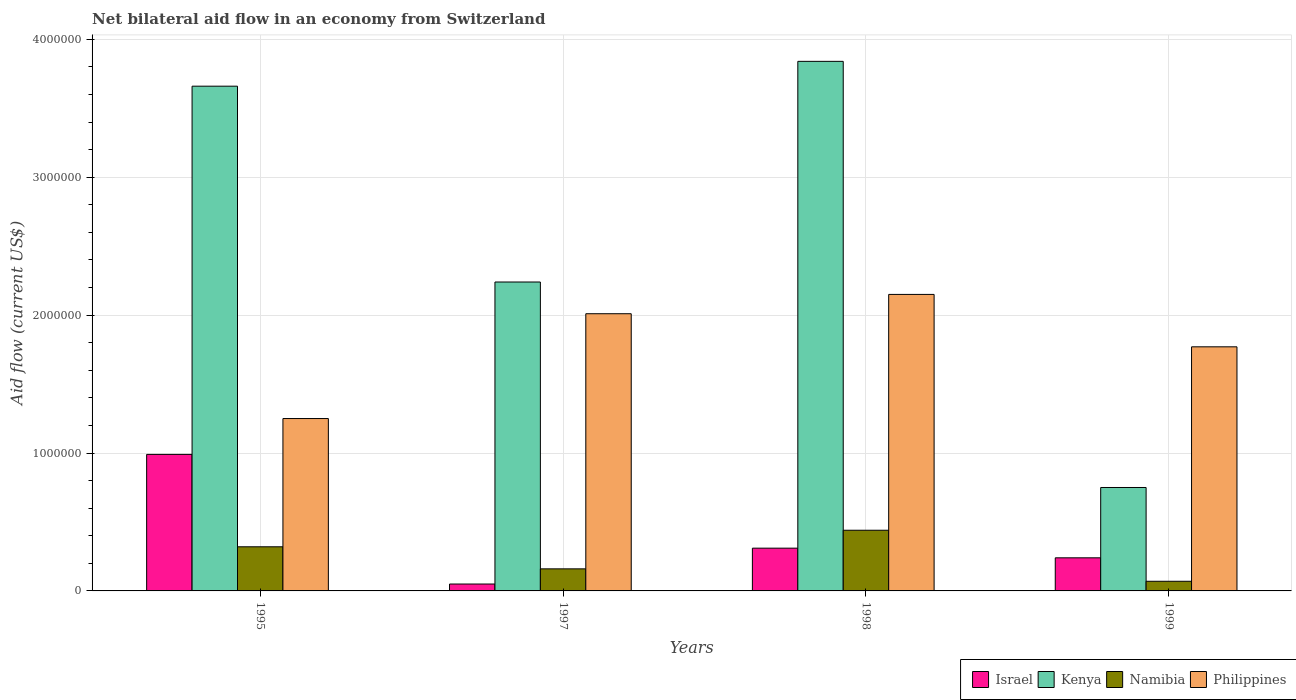How many different coloured bars are there?
Your response must be concise. 4. How many groups of bars are there?
Make the answer very short. 4. Are the number of bars per tick equal to the number of legend labels?
Your answer should be very brief. Yes. Are the number of bars on each tick of the X-axis equal?
Offer a terse response. Yes. How many bars are there on the 2nd tick from the left?
Offer a terse response. 4. What is the label of the 4th group of bars from the left?
Your answer should be compact. 1999. What is the net bilateral aid flow in Israel in 1995?
Offer a terse response. 9.90e+05. Across all years, what is the maximum net bilateral aid flow in Philippines?
Provide a short and direct response. 2.15e+06. Across all years, what is the minimum net bilateral aid flow in Philippines?
Provide a short and direct response. 1.25e+06. In which year was the net bilateral aid flow in Kenya maximum?
Ensure brevity in your answer.  1998. What is the total net bilateral aid flow in Israel in the graph?
Offer a terse response. 1.59e+06. What is the difference between the net bilateral aid flow in Namibia in 1997 and that in 1998?
Your answer should be very brief. -2.80e+05. What is the difference between the net bilateral aid flow in Kenya in 1997 and the net bilateral aid flow in Namibia in 1998?
Keep it short and to the point. 1.80e+06. What is the average net bilateral aid flow in Kenya per year?
Offer a very short reply. 2.62e+06. In the year 1999, what is the difference between the net bilateral aid flow in Namibia and net bilateral aid flow in Kenya?
Your response must be concise. -6.80e+05. What is the ratio of the net bilateral aid flow in Philippines in 1995 to that in 1998?
Ensure brevity in your answer.  0.58. What is the difference between the highest and the second highest net bilateral aid flow in Israel?
Provide a succinct answer. 6.80e+05. What is the difference between the highest and the lowest net bilateral aid flow in Israel?
Keep it short and to the point. 9.40e+05. In how many years, is the net bilateral aid flow in Israel greater than the average net bilateral aid flow in Israel taken over all years?
Your response must be concise. 1. What does the 2nd bar from the left in 1999 represents?
Make the answer very short. Kenya. What does the 4th bar from the right in 1998 represents?
Your answer should be compact. Israel. Are all the bars in the graph horizontal?
Give a very brief answer. No. How many years are there in the graph?
Your response must be concise. 4. What is the difference between two consecutive major ticks on the Y-axis?
Ensure brevity in your answer.  1.00e+06. Does the graph contain any zero values?
Provide a short and direct response. No. Does the graph contain grids?
Offer a very short reply. Yes. Where does the legend appear in the graph?
Your answer should be compact. Bottom right. What is the title of the graph?
Your response must be concise. Net bilateral aid flow in an economy from Switzerland. What is the label or title of the Y-axis?
Give a very brief answer. Aid flow (current US$). What is the Aid flow (current US$) in Israel in 1995?
Offer a terse response. 9.90e+05. What is the Aid flow (current US$) of Kenya in 1995?
Offer a very short reply. 3.66e+06. What is the Aid flow (current US$) of Namibia in 1995?
Make the answer very short. 3.20e+05. What is the Aid flow (current US$) in Philippines in 1995?
Your response must be concise. 1.25e+06. What is the Aid flow (current US$) in Kenya in 1997?
Provide a succinct answer. 2.24e+06. What is the Aid flow (current US$) of Philippines in 1997?
Your answer should be very brief. 2.01e+06. What is the Aid flow (current US$) of Kenya in 1998?
Your answer should be very brief. 3.84e+06. What is the Aid flow (current US$) in Philippines in 1998?
Offer a terse response. 2.15e+06. What is the Aid flow (current US$) in Kenya in 1999?
Provide a short and direct response. 7.50e+05. What is the Aid flow (current US$) in Namibia in 1999?
Ensure brevity in your answer.  7.00e+04. What is the Aid flow (current US$) of Philippines in 1999?
Give a very brief answer. 1.77e+06. Across all years, what is the maximum Aid flow (current US$) in Israel?
Your response must be concise. 9.90e+05. Across all years, what is the maximum Aid flow (current US$) in Kenya?
Your answer should be compact. 3.84e+06. Across all years, what is the maximum Aid flow (current US$) in Namibia?
Keep it short and to the point. 4.40e+05. Across all years, what is the maximum Aid flow (current US$) in Philippines?
Your answer should be very brief. 2.15e+06. Across all years, what is the minimum Aid flow (current US$) in Kenya?
Provide a short and direct response. 7.50e+05. Across all years, what is the minimum Aid flow (current US$) of Namibia?
Offer a very short reply. 7.00e+04. Across all years, what is the minimum Aid flow (current US$) in Philippines?
Provide a succinct answer. 1.25e+06. What is the total Aid flow (current US$) of Israel in the graph?
Provide a short and direct response. 1.59e+06. What is the total Aid flow (current US$) in Kenya in the graph?
Your response must be concise. 1.05e+07. What is the total Aid flow (current US$) of Namibia in the graph?
Your response must be concise. 9.90e+05. What is the total Aid flow (current US$) of Philippines in the graph?
Keep it short and to the point. 7.18e+06. What is the difference between the Aid flow (current US$) in Israel in 1995 and that in 1997?
Offer a very short reply. 9.40e+05. What is the difference between the Aid flow (current US$) of Kenya in 1995 and that in 1997?
Provide a short and direct response. 1.42e+06. What is the difference between the Aid flow (current US$) of Namibia in 1995 and that in 1997?
Give a very brief answer. 1.60e+05. What is the difference between the Aid flow (current US$) of Philippines in 1995 and that in 1997?
Give a very brief answer. -7.60e+05. What is the difference between the Aid flow (current US$) in Israel in 1995 and that in 1998?
Make the answer very short. 6.80e+05. What is the difference between the Aid flow (current US$) in Kenya in 1995 and that in 1998?
Offer a terse response. -1.80e+05. What is the difference between the Aid flow (current US$) of Philippines in 1995 and that in 1998?
Provide a short and direct response. -9.00e+05. What is the difference between the Aid flow (current US$) in Israel in 1995 and that in 1999?
Your answer should be very brief. 7.50e+05. What is the difference between the Aid flow (current US$) in Kenya in 1995 and that in 1999?
Offer a terse response. 2.91e+06. What is the difference between the Aid flow (current US$) of Philippines in 1995 and that in 1999?
Ensure brevity in your answer.  -5.20e+05. What is the difference between the Aid flow (current US$) in Kenya in 1997 and that in 1998?
Ensure brevity in your answer.  -1.60e+06. What is the difference between the Aid flow (current US$) of Namibia in 1997 and that in 1998?
Your response must be concise. -2.80e+05. What is the difference between the Aid flow (current US$) of Philippines in 1997 and that in 1998?
Offer a terse response. -1.40e+05. What is the difference between the Aid flow (current US$) in Israel in 1997 and that in 1999?
Make the answer very short. -1.90e+05. What is the difference between the Aid flow (current US$) of Kenya in 1997 and that in 1999?
Your answer should be compact. 1.49e+06. What is the difference between the Aid flow (current US$) in Namibia in 1997 and that in 1999?
Your answer should be compact. 9.00e+04. What is the difference between the Aid flow (current US$) of Philippines in 1997 and that in 1999?
Make the answer very short. 2.40e+05. What is the difference between the Aid flow (current US$) of Israel in 1998 and that in 1999?
Your answer should be compact. 7.00e+04. What is the difference between the Aid flow (current US$) in Kenya in 1998 and that in 1999?
Your answer should be compact. 3.09e+06. What is the difference between the Aid flow (current US$) of Namibia in 1998 and that in 1999?
Offer a very short reply. 3.70e+05. What is the difference between the Aid flow (current US$) of Israel in 1995 and the Aid flow (current US$) of Kenya in 1997?
Offer a very short reply. -1.25e+06. What is the difference between the Aid flow (current US$) of Israel in 1995 and the Aid flow (current US$) of Namibia in 1997?
Your response must be concise. 8.30e+05. What is the difference between the Aid flow (current US$) of Israel in 1995 and the Aid flow (current US$) of Philippines in 1997?
Your response must be concise. -1.02e+06. What is the difference between the Aid flow (current US$) in Kenya in 1995 and the Aid flow (current US$) in Namibia in 1997?
Your response must be concise. 3.50e+06. What is the difference between the Aid flow (current US$) of Kenya in 1995 and the Aid flow (current US$) of Philippines in 1997?
Make the answer very short. 1.65e+06. What is the difference between the Aid flow (current US$) of Namibia in 1995 and the Aid flow (current US$) of Philippines in 1997?
Your answer should be very brief. -1.69e+06. What is the difference between the Aid flow (current US$) in Israel in 1995 and the Aid flow (current US$) in Kenya in 1998?
Your answer should be compact. -2.85e+06. What is the difference between the Aid flow (current US$) of Israel in 1995 and the Aid flow (current US$) of Philippines in 1998?
Offer a terse response. -1.16e+06. What is the difference between the Aid flow (current US$) in Kenya in 1995 and the Aid flow (current US$) in Namibia in 1998?
Your response must be concise. 3.22e+06. What is the difference between the Aid flow (current US$) in Kenya in 1995 and the Aid flow (current US$) in Philippines in 1998?
Ensure brevity in your answer.  1.51e+06. What is the difference between the Aid flow (current US$) of Namibia in 1995 and the Aid flow (current US$) of Philippines in 1998?
Provide a succinct answer. -1.83e+06. What is the difference between the Aid flow (current US$) of Israel in 1995 and the Aid flow (current US$) of Kenya in 1999?
Keep it short and to the point. 2.40e+05. What is the difference between the Aid flow (current US$) of Israel in 1995 and the Aid flow (current US$) of Namibia in 1999?
Your answer should be compact. 9.20e+05. What is the difference between the Aid flow (current US$) in Israel in 1995 and the Aid flow (current US$) in Philippines in 1999?
Your answer should be compact. -7.80e+05. What is the difference between the Aid flow (current US$) of Kenya in 1995 and the Aid flow (current US$) of Namibia in 1999?
Provide a short and direct response. 3.59e+06. What is the difference between the Aid flow (current US$) in Kenya in 1995 and the Aid flow (current US$) in Philippines in 1999?
Make the answer very short. 1.89e+06. What is the difference between the Aid flow (current US$) in Namibia in 1995 and the Aid flow (current US$) in Philippines in 1999?
Provide a succinct answer. -1.45e+06. What is the difference between the Aid flow (current US$) in Israel in 1997 and the Aid flow (current US$) in Kenya in 1998?
Your response must be concise. -3.79e+06. What is the difference between the Aid flow (current US$) in Israel in 1997 and the Aid flow (current US$) in Namibia in 1998?
Make the answer very short. -3.90e+05. What is the difference between the Aid flow (current US$) of Israel in 1997 and the Aid flow (current US$) of Philippines in 1998?
Your answer should be compact. -2.10e+06. What is the difference between the Aid flow (current US$) of Kenya in 1997 and the Aid flow (current US$) of Namibia in 1998?
Your response must be concise. 1.80e+06. What is the difference between the Aid flow (current US$) of Kenya in 1997 and the Aid flow (current US$) of Philippines in 1998?
Your answer should be compact. 9.00e+04. What is the difference between the Aid flow (current US$) of Namibia in 1997 and the Aid flow (current US$) of Philippines in 1998?
Make the answer very short. -1.99e+06. What is the difference between the Aid flow (current US$) of Israel in 1997 and the Aid flow (current US$) of Kenya in 1999?
Keep it short and to the point. -7.00e+05. What is the difference between the Aid flow (current US$) in Israel in 1997 and the Aid flow (current US$) in Philippines in 1999?
Offer a terse response. -1.72e+06. What is the difference between the Aid flow (current US$) of Kenya in 1997 and the Aid flow (current US$) of Namibia in 1999?
Your response must be concise. 2.17e+06. What is the difference between the Aid flow (current US$) of Kenya in 1997 and the Aid flow (current US$) of Philippines in 1999?
Make the answer very short. 4.70e+05. What is the difference between the Aid flow (current US$) in Namibia in 1997 and the Aid flow (current US$) in Philippines in 1999?
Your response must be concise. -1.61e+06. What is the difference between the Aid flow (current US$) in Israel in 1998 and the Aid flow (current US$) in Kenya in 1999?
Keep it short and to the point. -4.40e+05. What is the difference between the Aid flow (current US$) of Israel in 1998 and the Aid flow (current US$) of Namibia in 1999?
Keep it short and to the point. 2.40e+05. What is the difference between the Aid flow (current US$) in Israel in 1998 and the Aid flow (current US$) in Philippines in 1999?
Ensure brevity in your answer.  -1.46e+06. What is the difference between the Aid flow (current US$) in Kenya in 1998 and the Aid flow (current US$) in Namibia in 1999?
Your answer should be compact. 3.77e+06. What is the difference between the Aid flow (current US$) of Kenya in 1998 and the Aid flow (current US$) of Philippines in 1999?
Offer a very short reply. 2.07e+06. What is the difference between the Aid flow (current US$) in Namibia in 1998 and the Aid flow (current US$) in Philippines in 1999?
Ensure brevity in your answer.  -1.33e+06. What is the average Aid flow (current US$) in Israel per year?
Give a very brief answer. 3.98e+05. What is the average Aid flow (current US$) of Kenya per year?
Your response must be concise. 2.62e+06. What is the average Aid flow (current US$) of Namibia per year?
Your answer should be compact. 2.48e+05. What is the average Aid flow (current US$) of Philippines per year?
Offer a very short reply. 1.80e+06. In the year 1995, what is the difference between the Aid flow (current US$) in Israel and Aid flow (current US$) in Kenya?
Ensure brevity in your answer.  -2.67e+06. In the year 1995, what is the difference between the Aid flow (current US$) in Israel and Aid flow (current US$) in Namibia?
Give a very brief answer. 6.70e+05. In the year 1995, what is the difference between the Aid flow (current US$) in Israel and Aid flow (current US$) in Philippines?
Offer a very short reply. -2.60e+05. In the year 1995, what is the difference between the Aid flow (current US$) of Kenya and Aid flow (current US$) of Namibia?
Give a very brief answer. 3.34e+06. In the year 1995, what is the difference between the Aid flow (current US$) of Kenya and Aid flow (current US$) of Philippines?
Offer a very short reply. 2.41e+06. In the year 1995, what is the difference between the Aid flow (current US$) in Namibia and Aid flow (current US$) in Philippines?
Offer a terse response. -9.30e+05. In the year 1997, what is the difference between the Aid flow (current US$) in Israel and Aid flow (current US$) in Kenya?
Ensure brevity in your answer.  -2.19e+06. In the year 1997, what is the difference between the Aid flow (current US$) in Israel and Aid flow (current US$) in Philippines?
Ensure brevity in your answer.  -1.96e+06. In the year 1997, what is the difference between the Aid flow (current US$) of Kenya and Aid flow (current US$) of Namibia?
Keep it short and to the point. 2.08e+06. In the year 1997, what is the difference between the Aid flow (current US$) of Namibia and Aid flow (current US$) of Philippines?
Provide a succinct answer. -1.85e+06. In the year 1998, what is the difference between the Aid flow (current US$) of Israel and Aid flow (current US$) of Kenya?
Provide a short and direct response. -3.53e+06. In the year 1998, what is the difference between the Aid flow (current US$) in Israel and Aid flow (current US$) in Namibia?
Your answer should be compact. -1.30e+05. In the year 1998, what is the difference between the Aid flow (current US$) of Israel and Aid flow (current US$) of Philippines?
Ensure brevity in your answer.  -1.84e+06. In the year 1998, what is the difference between the Aid flow (current US$) of Kenya and Aid flow (current US$) of Namibia?
Keep it short and to the point. 3.40e+06. In the year 1998, what is the difference between the Aid flow (current US$) in Kenya and Aid flow (current US$) in Philippines?
Keep it short and to the point. 1.69e+06. In the year 1998, what is the difference between the Aid flow (current US$) of Namibia and Aid flow (current US$) of Philippines?
Ensure brevity in your answer.  -1.71e+06. In the year 1999, what is the difference between the Aid flow (current US$) of Israel and Aid flow (current US$) of Kenya?
Provide a short and direct response. -5.10e+05. In the year 1999, what is the difference between the Aid flow (current US$) in Israel and Aid flow (current US$) in Philippines?
Make the answer very short. -1.53e+06. In the year 1999, what is the difference between the Aid flow (current US$) of Kenya and Aid flow (current US$) of Namibia?
Keep it short and to the point. 6.80e+05. In the year 1999, what is the difference between the Aid flow (current US$) in Kenya and Aid flow (current US$) in Philippines?
Offer a very short reply. -1.02e+06. In the year 1999, what is the difference between the Aid flow (current US$) in Namibia and Aid flow (current US$) in Philippines?
Your response must be concise. -1.70e+06. What is the ratio of the Aid flow (current US$) in Israel in 1995 to that in 1997?
Your answer should be very brief. 19.8. What is the ratio of the Aid flow (current US$) of Kenya in 1995 to that in 1997?
Ensure brevity in your answer.  1.63. What is the ratio of the Aid flow (current US$) of Philippines in 1995 to that in 1997?
Your answer should be very brief. 0.62. What is the ratio of the Aid flow (current US$) of Israel in 1995 to that in 1998?
Give a very brief answer. 3.19. What is the ratio of the Aid flow (current US$) of Kenya in 1995 to that in 1998?
Make the answer very short. 0.95. What is the ratio of the Aid flow (current US$) in Namibia in 1995 to that in 1998?
Make the answer very short. 0.73. What is the ratio of the Aid flow (current US$) in Philippines in 1995 to that in 1998?
Offer a very short reply. 0.58. What is the ratio of the Aid flow (current US$) in Israel in 1995 to that in 1999?
Offer a terse response. 4.12. What is the ratio of the Aid flow (current US$) of Kenya in 1995 to that in 1999?
Give a very brief answer. 4.88. What is the ratio of the Aid flow (current US$) in Namibia in 1995 to that in 1999?
Provide a short and direct response. 4.57. What is the ratio of the Aid flow (current US$) of Philippines in 1995 to that in 1999?
Provide a succinct answer. 0.71. What is the ratio of the Aid flow (current US$) in Israel in 1997 to that in 1998?
Provide a succinct answer. 0.16. What is the ratio of the Aid flow (current US$) of Kenya in 1997 to that in 1998?
Give a very brief answer. 0.58. What is the ratio of the Aid flow (current US$) of Namibia in 1997 to that in 1998?
Provide a succinct answer. 0.36. What is the ratio of the Aid flow (current US$) in Philippines in 1997 to that in 1998?
Keep it short and to the point. 0.93. What is the ratio of the Aid flow (current US$) of Israel in 1997 to that in 1999?
Make the answer very short. 0.21. What is the ratio of the Aid flow (current US$) of Kenya in 1997 to that in 1999?
Make the answer very short. 2.99. What is the ratio of the Aid flow (current US$) in Namibia in 1997 to that in 1999?
Provide a short and direct response. 2.29. What is the ratio of the Aid flow (current US$) in Philippines in 1997 to that in 1999?
Your response must be concise. 1.14. What is the ratio of the Aid flow (current US$) in Israel in 1998 to that in 1999?
Make the answer very short. 1.29. What is the ratio of the Aid flow (current US$) of Kenya in 1998 to that in 1999?
Make the answer very short. 5.12. What is the ratio of the Aid flow (current US$) in Namibia in 1998 to that in 1999?
Offer a very short reply. 6.29. What is the ratio of the Aid flow (current US$) in Philippines in 1998 to that in 1999?
Offer a terse response. 1.21. What is the difference between the highest and the second highest Aid flow (current US$) in Israel?
Your answer should be very brief. 6.80e+05. What is the difference between the highest and the second highest Aid flow (current US$) in Kenya?
Give a very brief answer. 1.80e+05. What is the difference between the highest and the second highest Aid flow (current US$) of Namibia?
Provide a short and direct response. 1.20e+05. What is the difference between the highest and the second highest Aid flow (current US$) in Philippines?
Your answer should be compact. 1.40e+05. What is the difference between the highest and the lowest Aid flow (current US$) in Israel?
Offer a terse response. 9.40e+05. What is the difference between the highest and the lowest Aid flow (current US$) in Kenya?
Ensure brevity in your answer.  3.09e+06. What is the difference between the highest and the lowest Aid flow (current US$) in Namibia?
Your response must be concise. 3.70e+05. What is the difference between the highest and the lowest Aid flow (current US$) of Philippines?
Keep it short and to the point. 9.00e+05. 